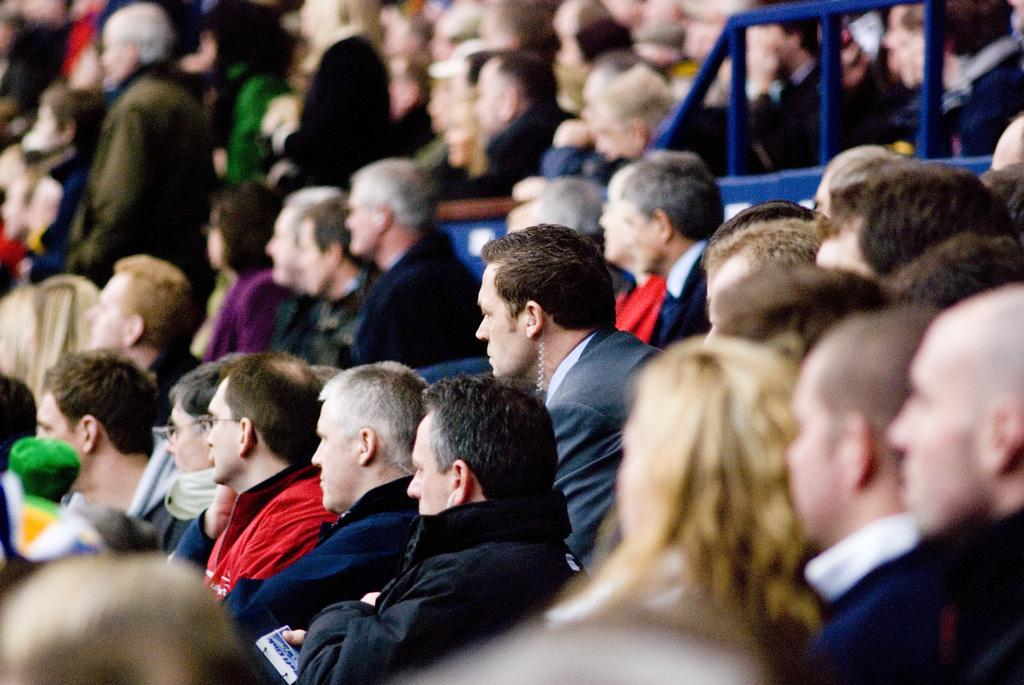What is the main subject of the image? The main subject of the image is a group of people. Can you describe the attire of the people in the image? The people in the image are wearing different color dresses. What can be observed about the background of the image? The background of the image blurred. How many snakes are present in the image? There are no snakes present in the image; it features a group of people wearing different color dresses. What type of work are the people in the image engaged in? The image does not provide any information about the work or occupation of the people. 